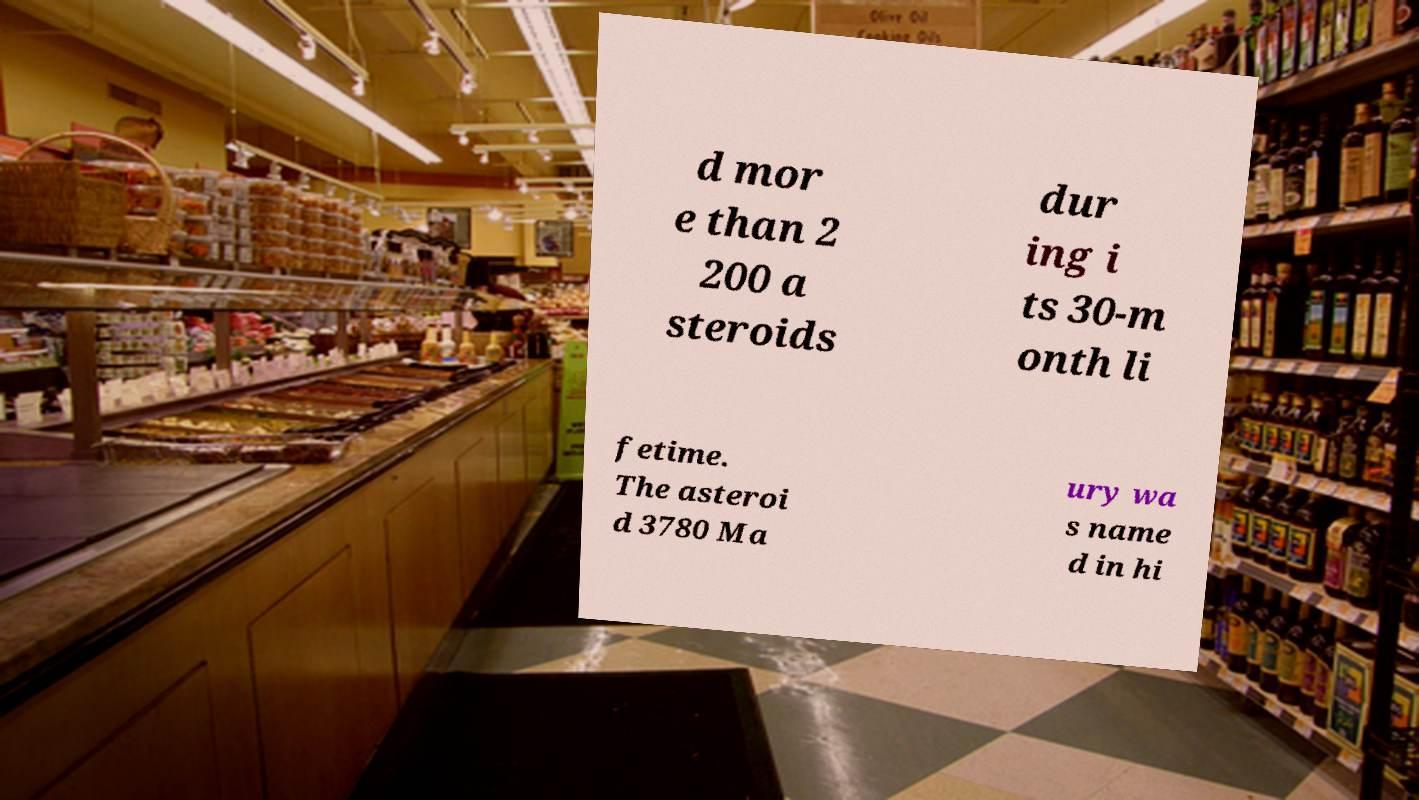What messages or text are displayed in this image? I need them in a readable, typed format. d mor e than 2 200 a steroids dur ing i ts 30-m onth li fetime. The asteroi d 3780 Ma ury wa s name d in hi 